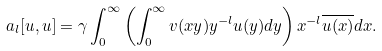<formula> <loc_0><loc_0><loc_500><loc_500>a _ { l } [ u , u ] = \gamma \int _ { 0 } ^ { \infty } \left ( \int _ { 0 } ^ { \infty } v ( x y ) y ^ { - l } u ( y ) d y \right ) x ^ { - l } \overline { u ( x ) } d x .</formula> 